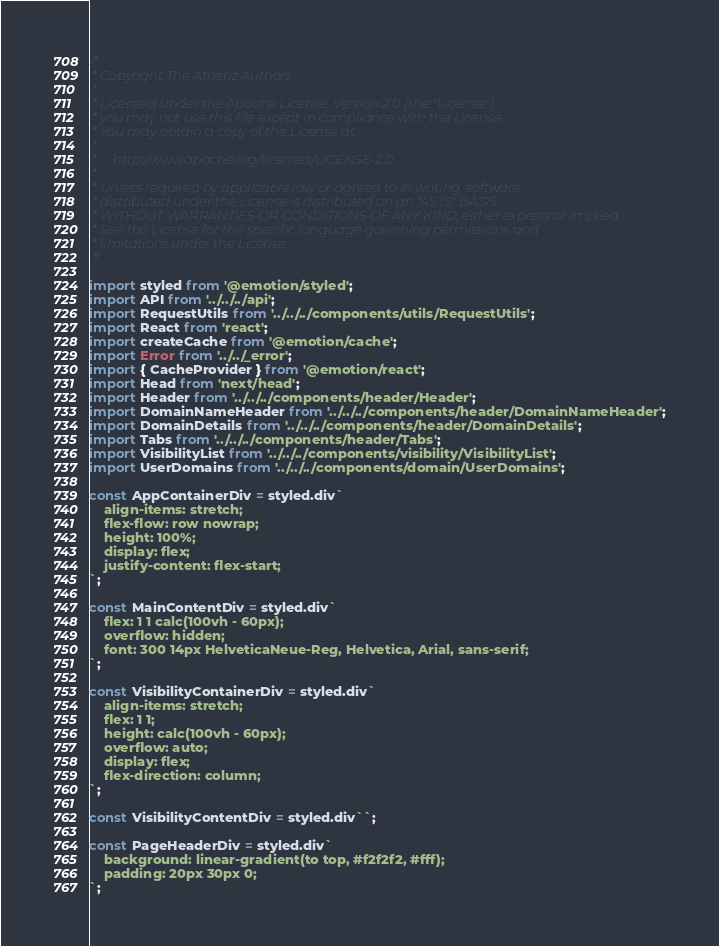<code> <loc_0><loc_0><loc_500><loc_500><_JavaScript_>/*
 * Copyright The Athenz Authors
 *
 * Licensed under the Apache License, Version 2.0 (the "License");
 * you may not use this file except in compliance with the License.
 * You may obtain a copy of the License at
 *
 *     http://www.apache.org/licenses/LICENSE-2.0
 *
 * Unless required by applicable law or agreed to in writing, software
 * distributed under the License is distributed on an "AS IS" BASIS,
 * WITHOUT WARRANTIES OR CONDITIONS OF ANY KIND, either express or implied.
 * See the License for the specific language governing permissions and
 * limitations under the License.
 */

import styled from '@emotion/styled';
import API from '../../../api';
import RequestUtils from '../../../components/utils/RequestUtils';
import React from 'react';
import createCache from '@emotion/cache';
import Error from '../../_error';
import { CacheProvider } from '@emotion/react';
import Head from 'next/head';
import Header from '../../../components/header/Header';
import DomainNameHeader from '../../../components/header/DomainNameHeader';
import DomainDetails from '../../../components/header/DomainDetails';
import Tabs from '../../../components/header/Tabs';
import VisibilityList from '../../../components/visibility/VisibilityList';
import UserDomains from '../../../components/domain/UserDomains';

const AppContainerDiv = styled.div`
    align-items: stretch;
    flex-flow: row nowrap;
    height: 100%;
    display: flex;
    justify-content: flex-start;
`;

const MainContentDiv = styled.div`
    flex: 1 1 calc(100vh - 60px);
    overflow: hidden;
    font: 300 14px HelveticaNeue-Reg, Helvetica, Arial, sans-serif;
`;

const VisibilityContainerDiv = styled.div`
    align-items: stretch;
    flex: 1 1;
    height: calc(100vh - 60px);
    overflow: auto;
    display: flex;
    flex-direction: column;
`;

const VisibilityContentDiv = styled.div``;

const PageHeaderDiv = styled.div`
    background: linear-gradient(to top, #f2f2f2, #fff);
    padding: 20px 30px 0;
`;
</code> 